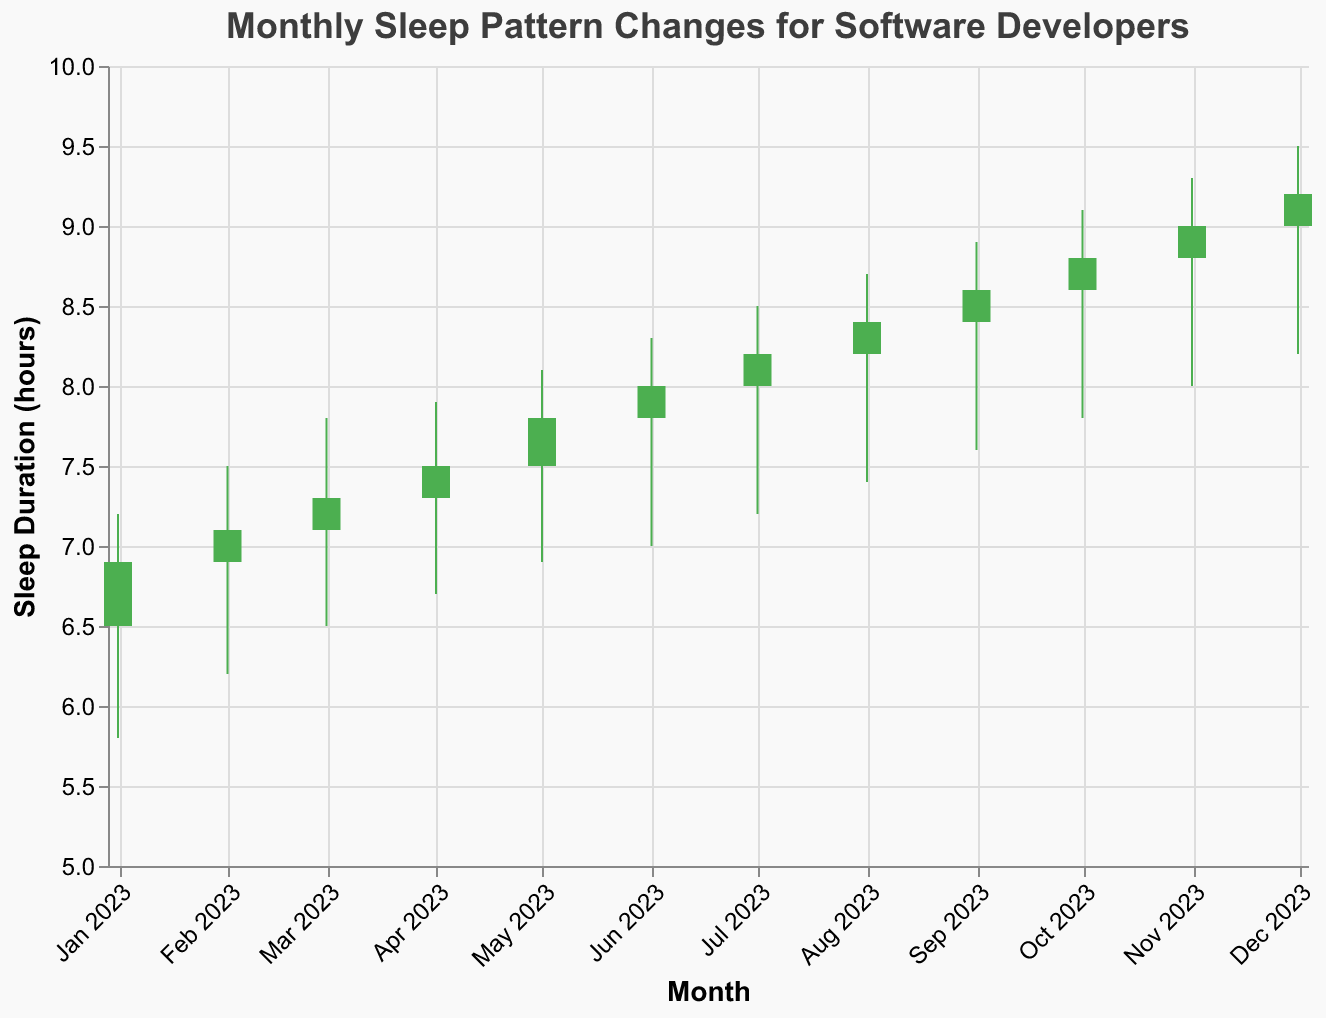What's the title of the chart? The title is centered at the top of the chart, and it specifies the topic of the chart. It reads "Monthly Sleep Pattern Changes for Software Developers".
Answer: Monthly Sleep Pattern Changes for Software Developers How many months of data are represented in the chart? The chart shows one data point for each month, and the x-axis labels indicate twelve months from January to December 2023.
Answer: 12 What is the sleep duration range for January 2023? For January 2023, the vertical rule represents the range from the Low value to the High value, which is from 5.8 hours to 7.2 hours.
Answer: 5.8 to 7.2 hours In which month was the lowest sleep duration recorded, and what was the value? The lowest sleep duration is represented by the smallest Low value on the y-axis. January 2023 has the lowest value of 5.8 hours.
Answer: January 2023, 5.8 hours What is the trend in the average sleep duration from January to December 2023? To determine the trend, observe the Open and Close values. Since both values generally increase over the months, the average sleep duration shows an increasing trend.
Answer: Increasing trend Which month shows the largest range in sleep duration? The range in sleep duration is represented by the vertical rule, which is the difference between the High and Low values. The month with the largest range is March 2023 (7.8 - 6.5 = 1.3 hours).
Answer: March 2023 How many months had an increase in closing sleep duration compared to the opening sleep duration? This can be determined by comparing the Open and Close values, where the bar is green if Open < Close. All months show an increase except January.
Answer: 11 months What is the average closing sleep duration for the first quarter (January to March) of 2023? The closing sleep durations for January, February, and March are 6.9, 7.1, and 7.3 hours respectively. Sum these values and divide by 3: (6.9 + 7.1 + 7.3) / 3 = 7.1 hours.
Answer: 7.1 hours Which month showed the highest maximum sleep duration, and what was the value? The highest maximum sleep duration is represented by the largest High value on the y-axis. December 2023 has the highest value of 9.5 hours.
Answer: December 2023, 9.5 hours What is the correlation between the number of hours slept and the month progression throughout the year? The correlation can be inferred by observing the overall trend of Open and Close values. Both increase steadily, indicating a positive correlation between longer sleep duration and month progression.
Answer: Positive correlation 